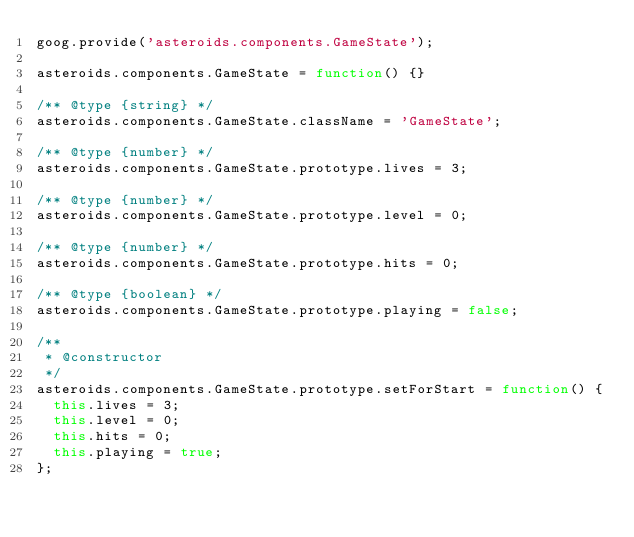Convert code to text. <code><loc_0><loc_0><loc_500><loc_500><_JavaScript_>goog.provide('asteroids.components.GameState');

asteroids.components.GameState = function() {}

/** @type {string} */
asteroids.components.GameState.className = 'GameState';

/** @type {number} */
asteroids.components.GameState.prototype.lives = 3;

/** @type {number} */
asteroids.components.GameState.prototype.level = 0;

/** @type {number} */
asteroids.components.GameState.prototype.hits = 0;

/** @type {boolean} */
asteroids.components.GameState.prototype.playing = false;

/**
 * @constructor
 */
asteroids.components.GameState.prototype.setForStart = function() {
  this.lives = 3;
  this.level = 0;
  this.hits = 0;
  this.playing = true;
};</code> 